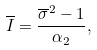Convert formula to latex. <formula><loc_0><loc_0><loc_500><loc_500>\overline { I } = \frac { \overline { \sigma } ^ { 2 } - 1 } { \alpha _ { 2 } } ,</formula> 